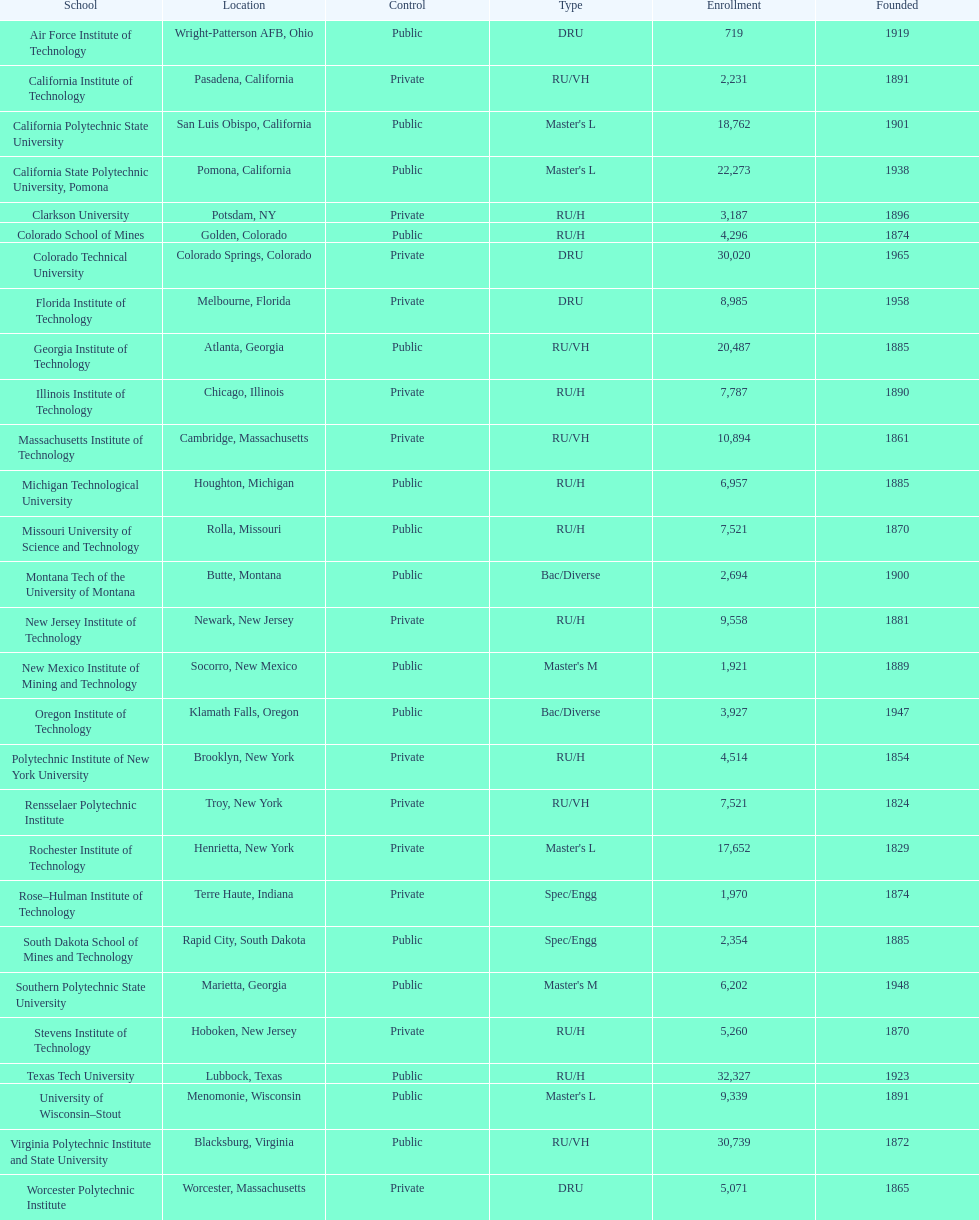What is the difference in enrollment between the top 2 schools listed in the table? 1512. 